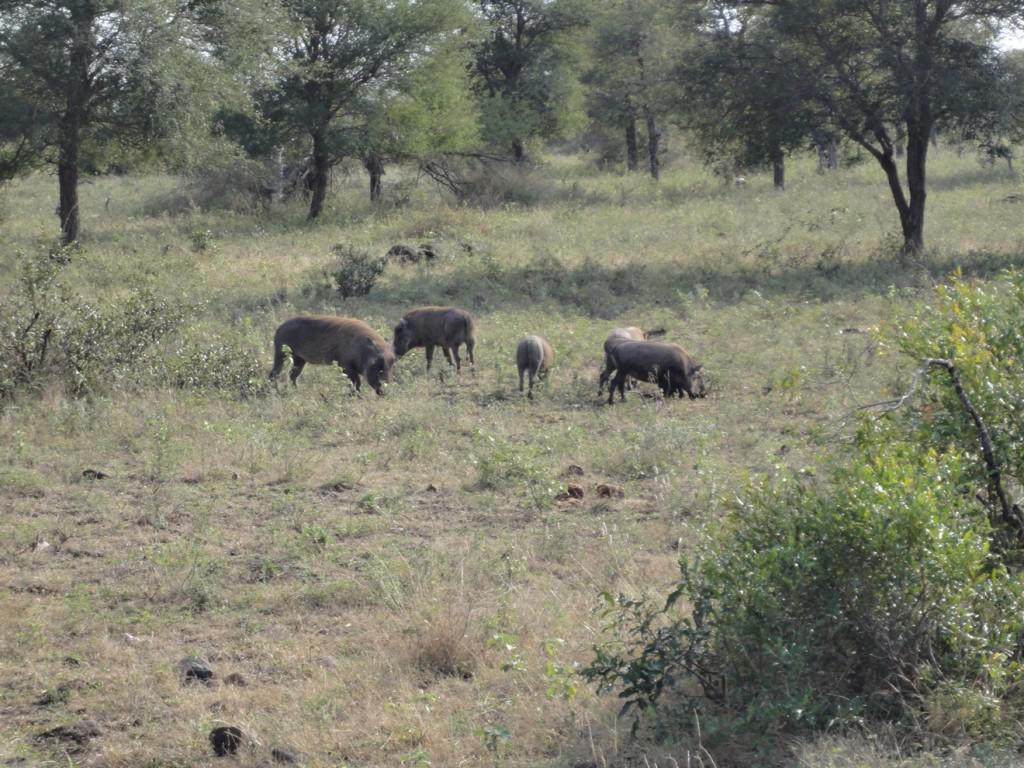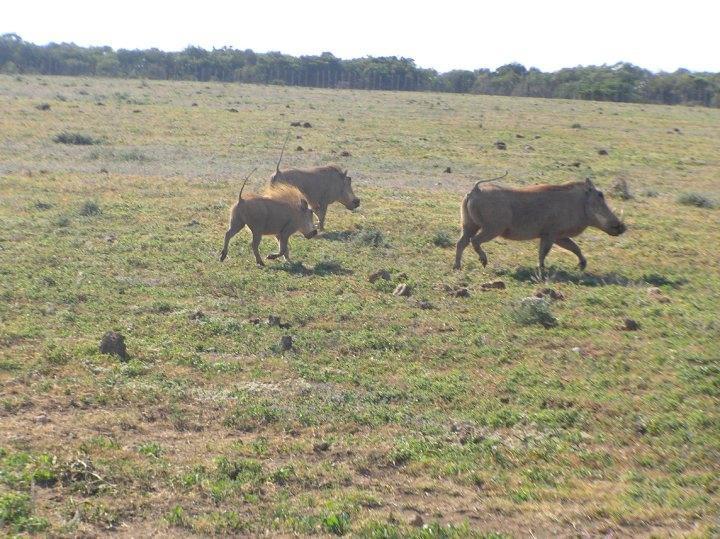The first image is the image on the left, the second image is the image on the right. Analyze the images presented: Is the assertion "Warthogs are standing in front of a body of nearby visible water, in one image." valid? Answer yes or no. No. The first image is the image on the left, the second image is the image on the right. Examine the images to the left and right. Is the description "The warthogs in one image are next to a body of water." accurate? Answer yes or no. No. 